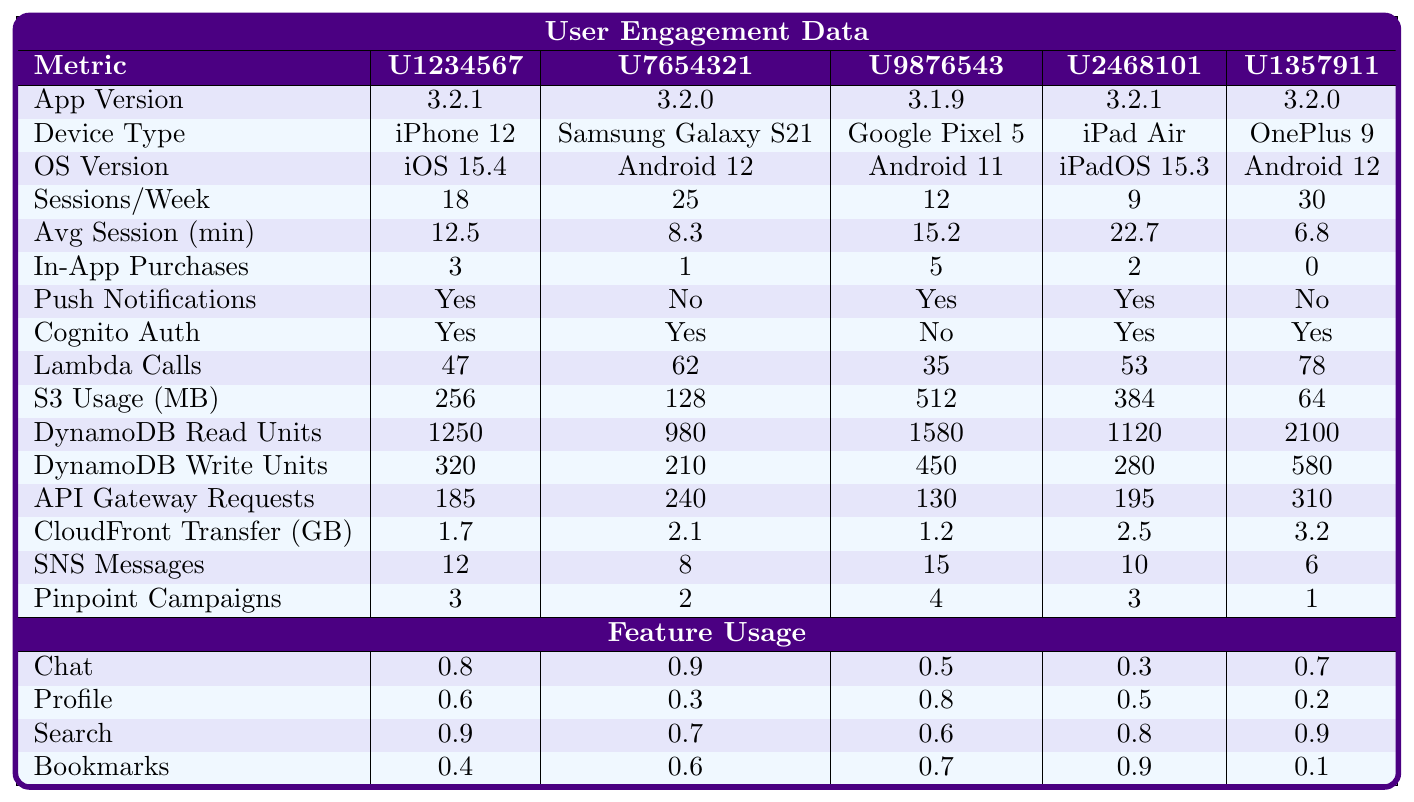What is the total number of in-app purchases made by U9876543? The table shows that U9876543 has made a total of 5 in-app purchases.
Answer: 5 What operating system does U1357911 use? According to the table, U1357911 is using Android 12.
Answer: Android 12 Which user has the highest average session duration? By comparing the average session durations in the table, U2468101 has the highest at 22.7 minutes.
Answer: U2468101 Is push notifications enabled for U7654321? The table indicates that U7654321 does not have push notifications enabled.
Answer: No What is the average number of sessions per week among all users? To find the average, sum the sessions: (18 + 25 + 12 + 9 + 30) = 94; then divide by the number of users (5): 94/5 = 18.8.
Answer: 18.8 How many Lambda function calls did U1357911 make compared to U2468101? U1357911 made 78 Lambda function calls, while U2468101 made 53 calls. The difference is 78 - 53 = 25.
Answer: 25 Which user has engaged with the least number of Pinpoint campaigns? Comparing the Pinpoint campaigns engaged, U1357911 has engaged with only 1 campaign, the least among all users.
Answer: U1357911 How much S3 storage usage (in MB) does U9876543 have compared to U1234567? U9876543 has 512 MB of S3 storage and U1234567 has 256 MB. The difference is 512 - 256 = 256 MB more for U9876543.
Answer: 256 MB Which feature has the highest usage rate for U7654321? The usage rates for U7654321 show Chat at 0.9, which is the highest among its features.
Answer: Chat How does the total DynamoDB Write Units for all users compare when looking for the user with the lowest write units? U1357911 has the lowest DynamoDB Write Units at 580 while summing others gives: 320 + 210 + 450 + 280 = 1260. The lowest is 580.
Answer: 580 